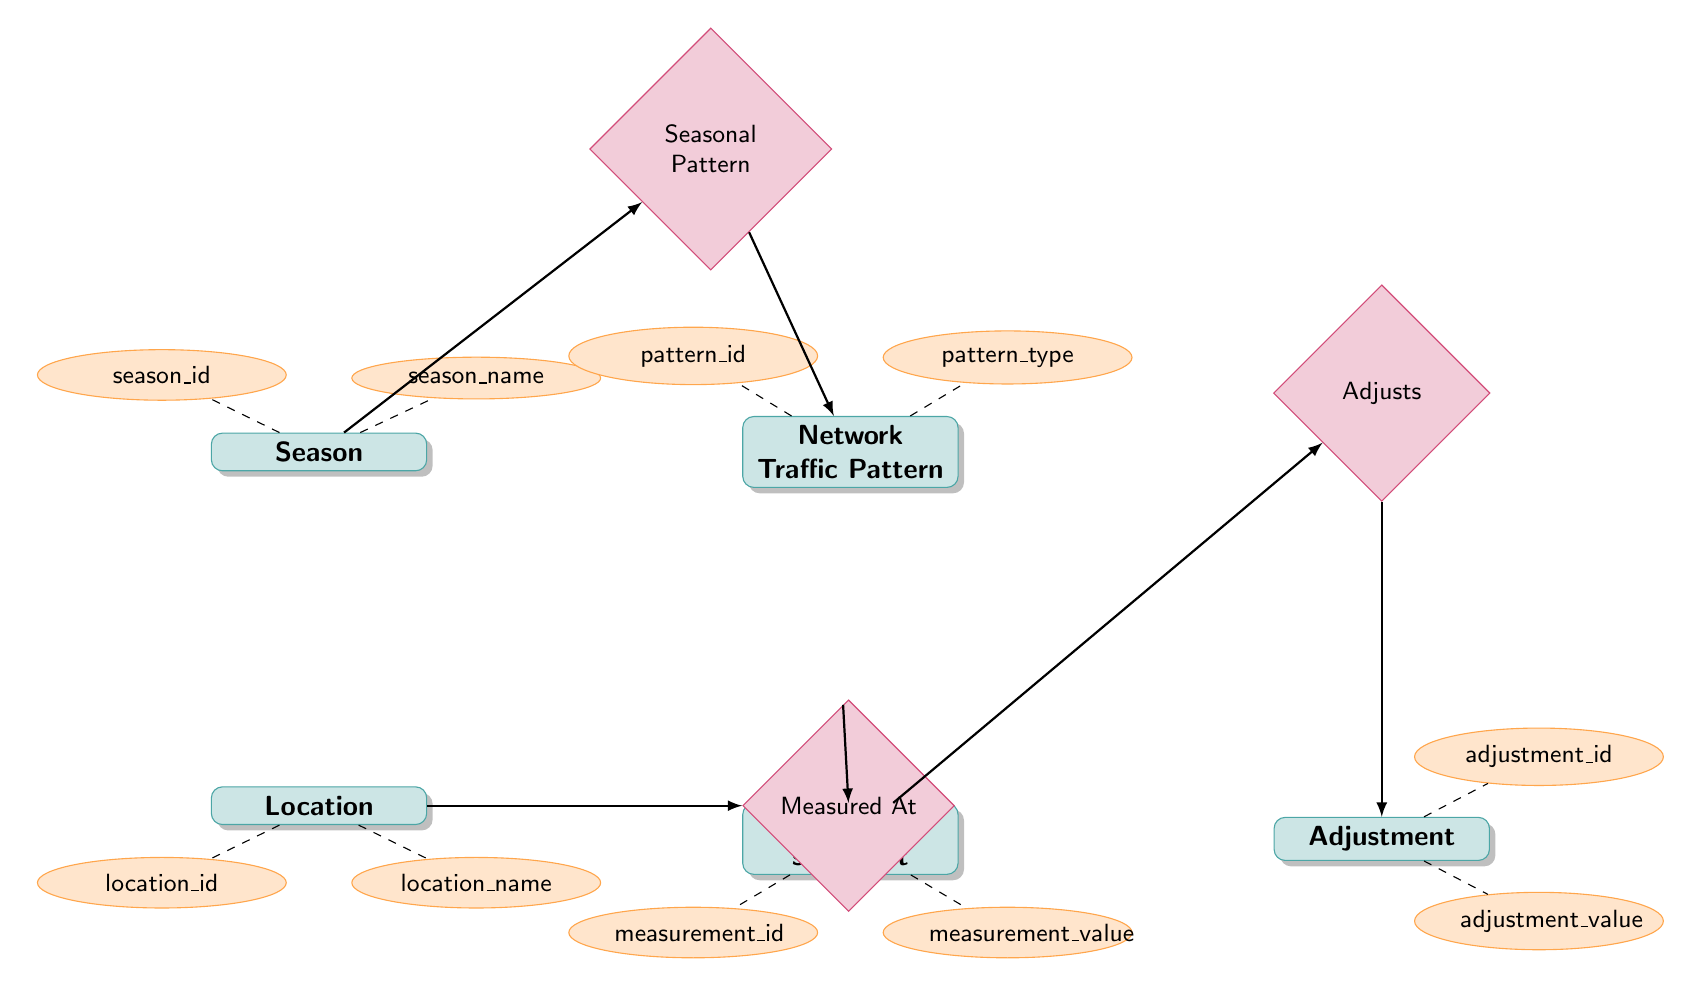What is the maximum number of RF Measurements for a single Location? The relationship between Location and RF Measurement is one-to-many. This indicates that one Location can have multiple RF Measurements recorded. However, the exact count is not provided in the diagram. Hence, while there is no maximum number indicated explicitly, any single Location could potentially have numerous RF Measurements depending on operational requirements.
Answer: many What is the relationship between Season and Network Traffic Pattern? The diagram shows a one-to-many relationship named "Seasonal Pattern" between Season and Network Traffic Pattern. This means a single Season can relate to multiple Network Traffic Patterns.
Answer: one-to-many How many attributes does the Adjustment entity have? Counting the attributes listed under the Adjustment entity, which are adjustment_id and adjustment_value, we find there are two attributes.
Answer: two Which entity has an attribute named location_name? The multiple attributes of entities can be identified visually. The location_name attribute is part of the Location entity.
Answer: Location What is the purpose of the Adjustment entity in relation to RF Measurement? The relationship "Adjusts" connects RF Measurement and Adjustment entities in a one-to-many fashion. This means each RF Measurement can have multiple Adjustments for refining the measurement values.
Answer: adjustments Which entity can have seasonal_id as an attribute? The seasonal_id attribute is an identifiable part of the Season entity according to the diagram.
Answer: Season Name a type of measurement taken at a specific location. The entity RF Measurement captures specific measurements taken, and it can relate to a Location through the relationship "Measured At". Any measurement represented here can illustrate traffic data collected at the specified location.
Answer: RF Measurement What does the relationship "Measured At" signify? The relationship "Measured At" signifies that there can be multiple RF Measurements taken at each Location, establishing a connection between them. It's a structural link that identifies from where measurements are sourced.
Answer: It signifies measurement collection at locations How many entities are in the diagram? By visually counting the entities depicted in the diagram—Season, Location, Network Traffic Pattern, RF Measurement, and Adjustment—we find there are five entities in total.
Answer: five 